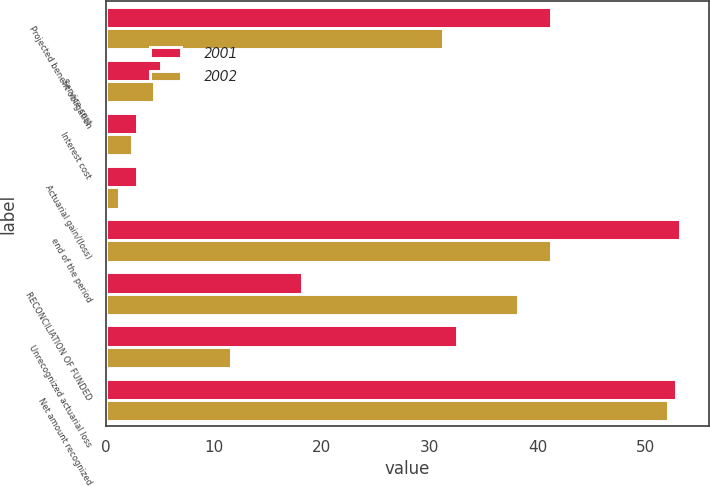Convert chart to OTSL. <chart><loc_0><loc_0><loc_500><loc_500><stacked_bar_chart><ecel><fcel>Projected benefit obligation<fcel>Service cost<fcel>Interest cost<fcel>Actuarial gain/(loss)<fcel>end of the period<fcel>RECONCILIATION OF FUNDED<fcel>Unrecognized actuarial loss<fcel>Net amount recognized<nl><fcel>2001<fcel>41.2<fcel>5.1<fcel>2.9<fcel>2.9<fcel>53.2<fcel>18.2<fcel>32.5<fcel>52.8<nl><fcel>2002<fcel>31.2<fcel>4.4<fcel>2.4<fcel>1.2<fcel>41.2<fcel>38.2<fcel>11.6<fcel>52.1<nl></chart> 